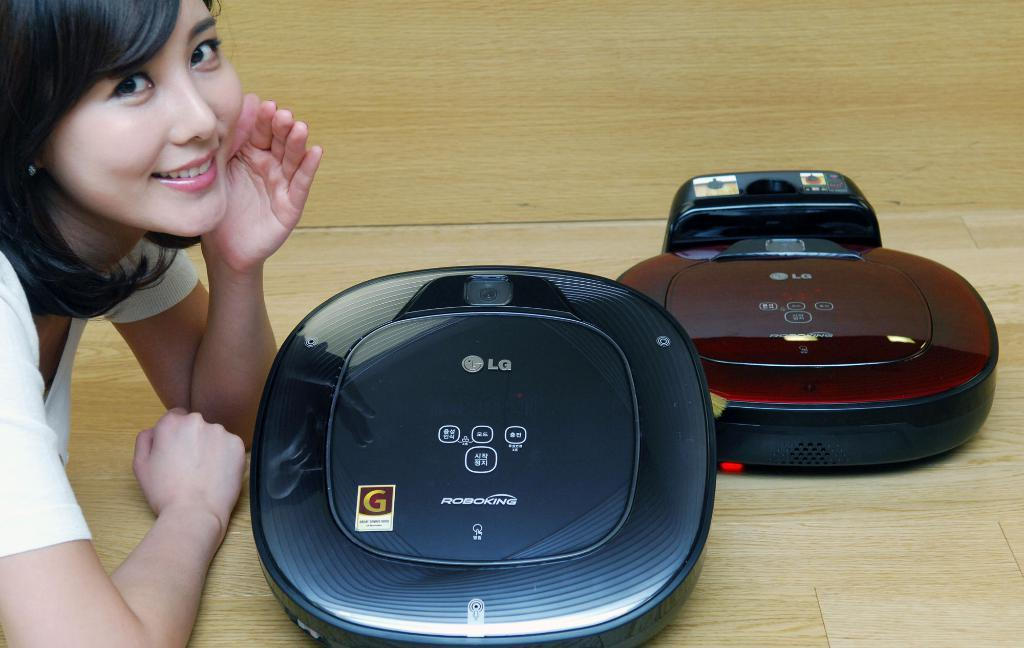Provide a one-sentence caption for the provided image. Two  Roboking devices that have the LG logo on the front. 